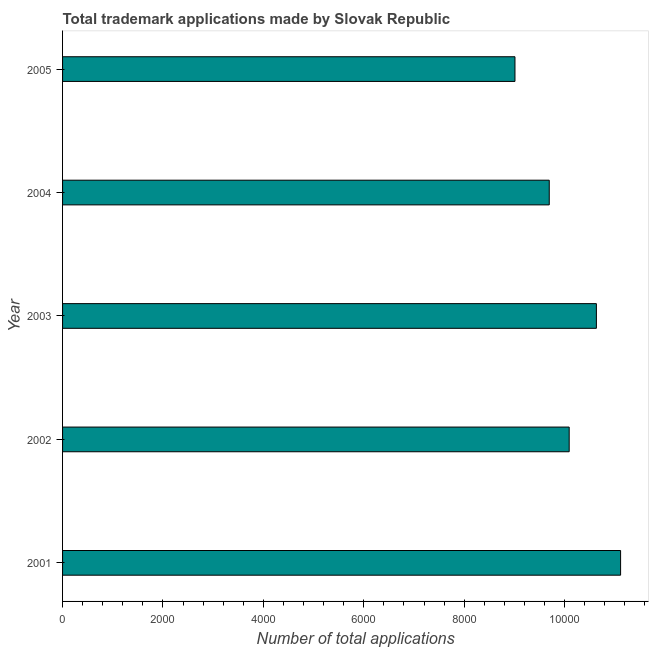What is the title of the graph?
Give a very brief answer. Total trademark applications made by Slovak Republic. What is the label or title of the X-axis?
Provide a succinct answer. Number of total applications. What is the number of trademark applications in 2004?
Your response must be concise. 9695. Across all years, what is the maximum number of trademark applications?
Give a very brief answer. 1.11e+04. Across all years, what is the minimum number of trademark applications?
Give a very brief answer. 9012. What is the sum of the number of trademark applications?
Offer a very short reply. 5.05e+04. What is the difference between the number of trademark applications in 2002 and 2004?
Keep it short and to the point. 397. What is the average number of trademark applications per year?
Make the answer very short. 1.01e+04. What is the median number of trademark applications?
Your answer should be very brief. 1.01e+04. Do a majority of the years between 2001 and 2005 (inclusive) have number of trademark applications greater than 10000 ?
Provide a succinct answer. Yes. What is the ratio of the number of trademark applications in 2003 to that in 2005?
Keep it short and to the point. 1.18. What is the difference between the highest and the second highest number of trademark applications?
Your answer should be very brief. 482. Is the sum of the number of trademark applications in 2001 and 2005 greater than the maximum number of trademark applications across all years?
Your response must be concise. Yes. What is the difference between the highest and the lowest number of trademark applications?
Make the answer very short. 2104. In how many years, is the number of trademark applications greater than the average number of trademark applications taken over all years?
Your answer should be very brief. 2. What is the Number of total applications of 2001?
Make the answer very short. 1.11e+04. What is the Number of total applications of 2002?
Your response must be concise. 1.01e+04. What is the Number of total applications of 2003?
Ensure brevity in your answer.  1.06e+04. What is the Number of total applications in 2004?
Give a very brief answer. 9695. What is the Number of total applications of 2005?
Offer a very short reply. 9012. What is the difference between the Number of total applications in 2001 and 2002?
Provide a short and direct response. 1024. What is the difference between the Number of total applications in 2001 and 2003?
Ensure brevity in your answer.  482. What is the difference between the Number of total applications in 2001 and 2004?
Provide a succinct answer. 1421. What is the difference between the Number of total applications in 2001 and 2005?
Offer a terse response. 2104. What is the difference between the Number of total applications in 2002 and 2003?
Make the answer very short. -542. What is the difference between the Number of total applications in 2002 and 2004?
Your response must be concise. 397. What is the difference between the Number of total applications in 2002 and 2005?
Your answer should be compact. 1080. What is the difference between the Number of total applications in 2003 and 2004?
Keep it short and to the point. 939. What is the difference between the Number of total applications in 2003 and 2005?
Your answer should be compact. 1622. What is the difference between the Number of total applications in 2004 and 2005?
Give a very brief answer. 683. What is the ratio of the Number of total applications in 2001 to that in 2002?
Offer a terse response. 1.1. What is the ratio of the Number of total applications in 2001 to that in 2003?
Offer a very short reply. 1.04. What is the ratio of the Number of total applications in 2001 to that in 2004?
Your answer should be compact. 1.15. What is the ratio of the Number of total applications in 2001 to that in 2005?
Provide a short and direct response. 1.23. What is the ratio of the Number of total applications in 2002 to that in 2003?
Your answer should be compact. 0.95. What is the ratio of the Number of total applications in 2002 to that in 2004?
Make the answer very short. 1.04. What is the ratio of the Number of total applications in 2002 to that in 2005?
Offer a terse response. 1.12. What is the ratio of the Number of total applications in 2003 to that in 2004?
Make the answer very short. 1.1. What is the ratio of the Number of total applications in 2003 to that in 2005?
Provide a succinct answer. 1.18. What is the ratio of the Number of total applications in 2004 to that in 2005?
Your answer should be very brief. 1.08. 